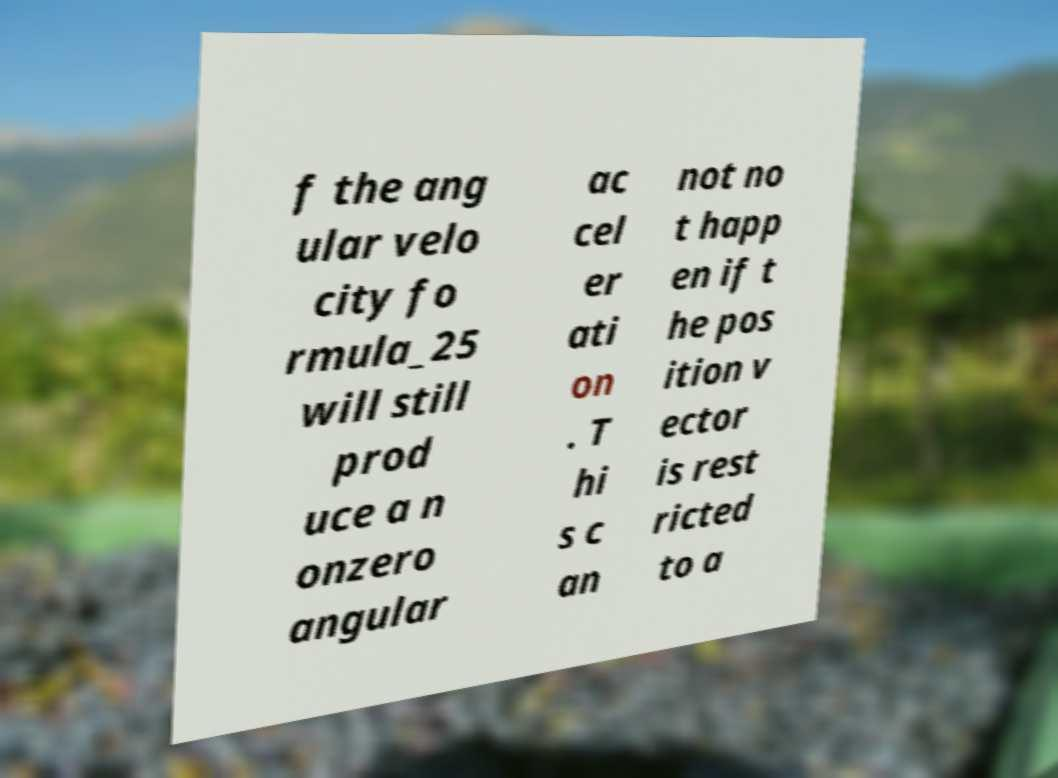Can you read and provide the text displayed in the image?This photo seems to have some interesting text. Can you extract and type it out for me? f the ang ular velo city fo rmula_25 will still prod uce a n onzero angular ac cel er ati on . T hi s c an not no t happ en if t he pos ition v ector is rest ricted to a 